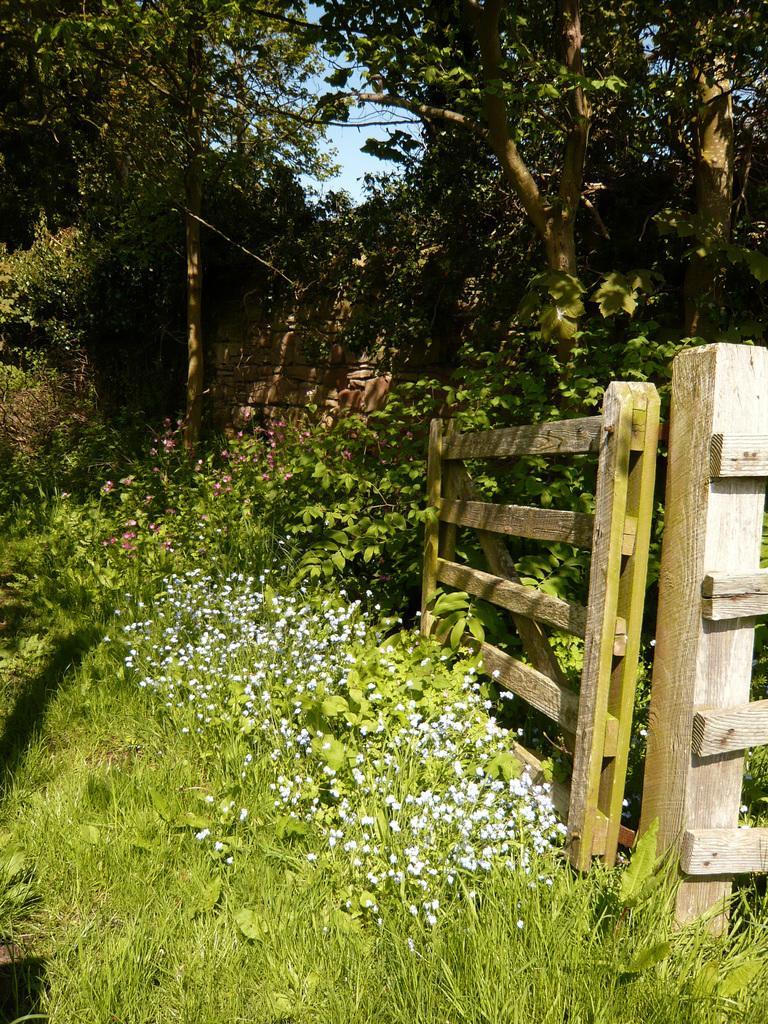Describe this image in one or two sentences. In this image there is a fence on the grassland having few plants with flowers. There is a wall. Background there are few trees. Behind there is sky. 